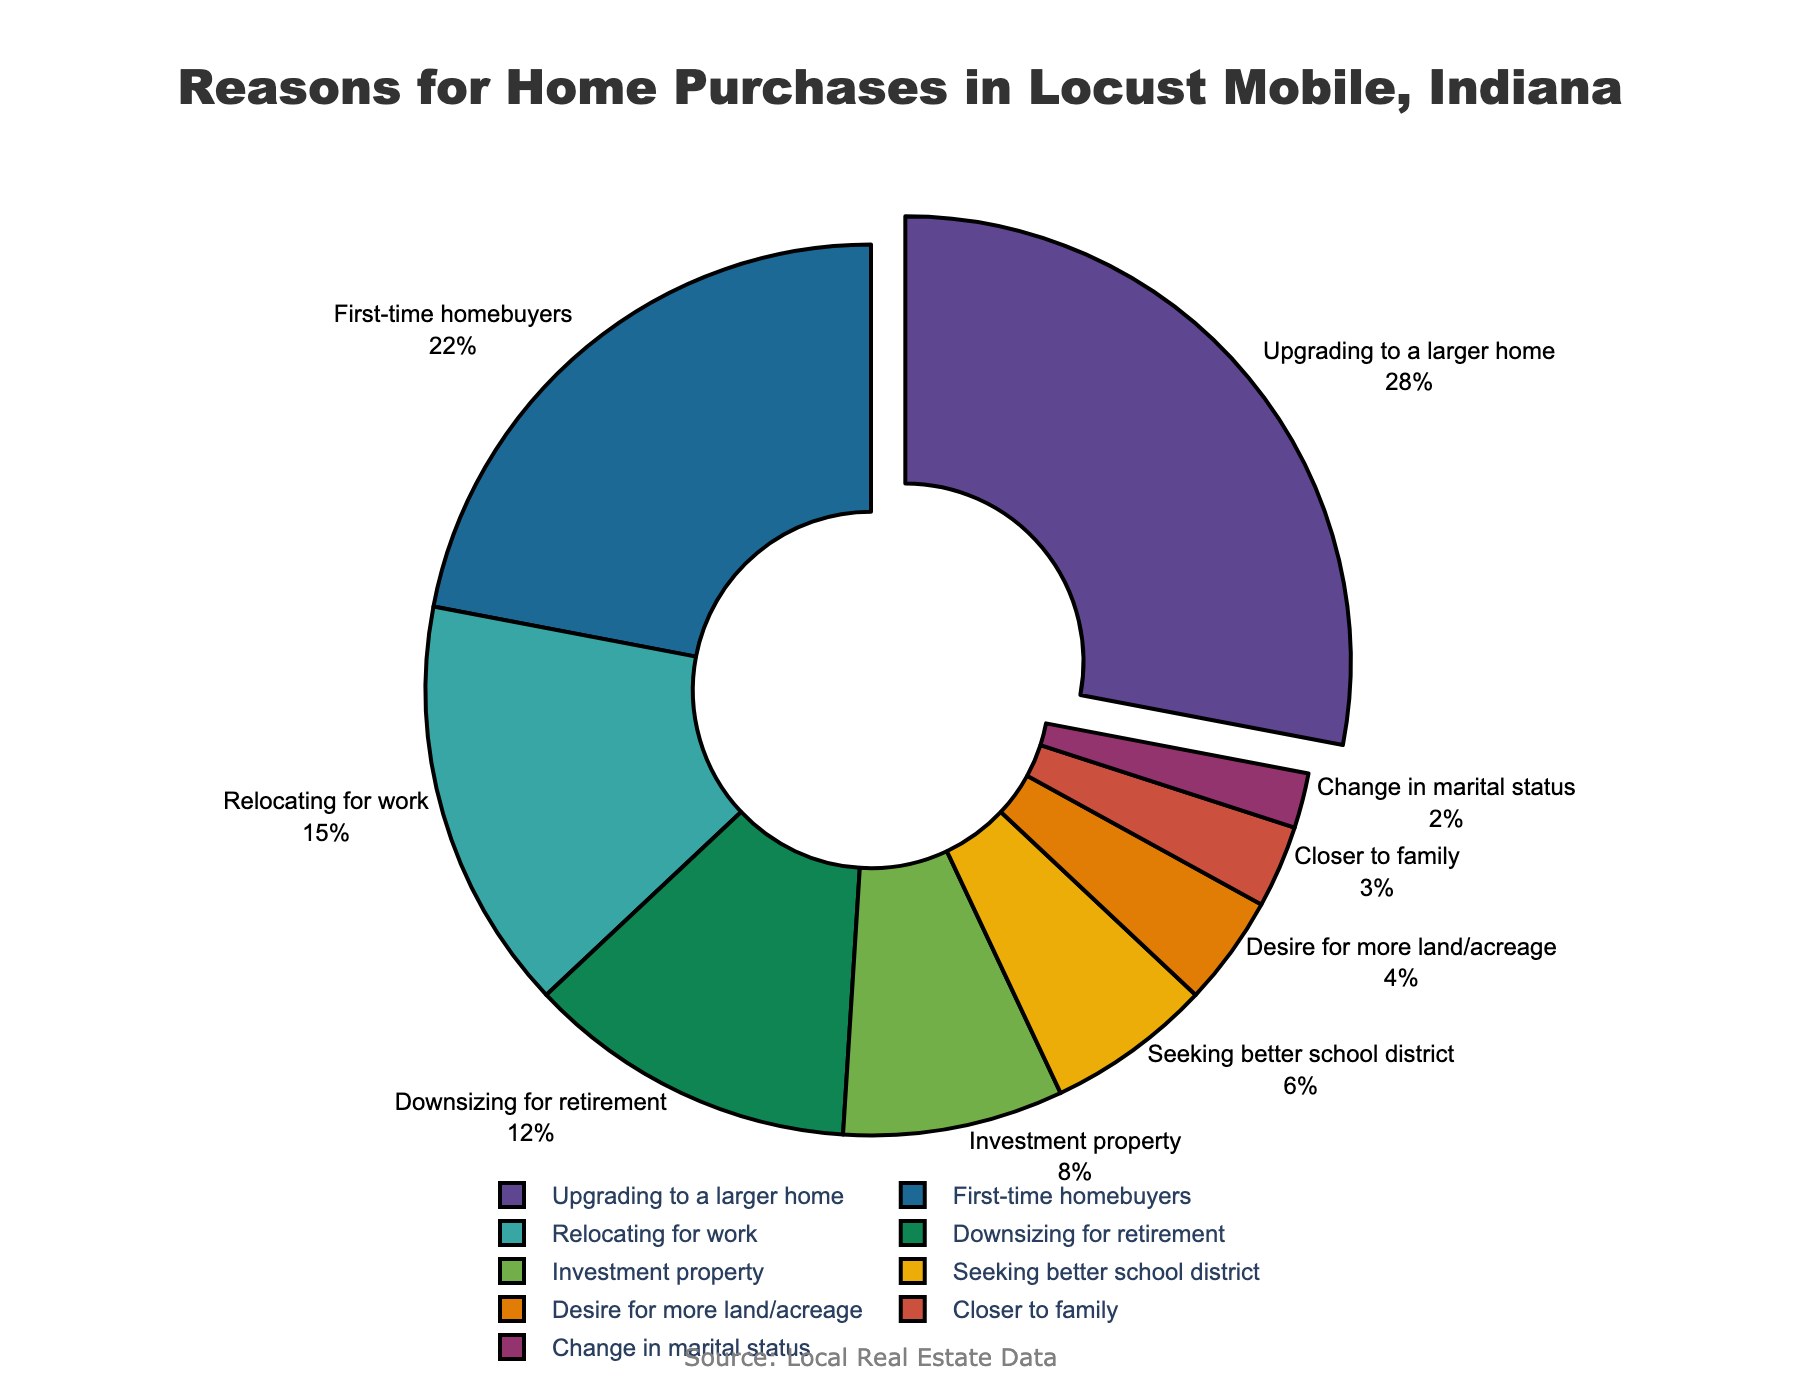What's the largest category among the reasons for home purchases? The largest category can be identified by the segment of the pie chart that is pulled out slightly and has the highest percentage labeled. This segment represents "Upgrading to a larger home" with 28%.
Answer: Upgrading to a larger home Which two categories together constitute exactly half of the reasons for home purchases? Adding the percentages of "Upgrading to a larger home" (28%) and "First-time homebuyers" (22%), we get 28% + 22% = 50%, which together amount to half of the reasons.
Answer: Upgrading to a larger home, First-time homebuyers How many percentage points more is "Relocating for work" compared to "Downsizing for retirement"? The percentage for "Relocating for work" is 15%, and for "Downsizing for retirement" is 12%. The difference is 15% - 12% = 3 percentage points more.
Answer: 3 percentage points What percentage of reasons for home purchases are related to "Seeking better school district" and "Desire for more land/acreage" combined? Adding the percentages for "Seeking better school district" (6%) and "Desire for more land/acreage" (4%), we get 6% + 4% = 10%.
Answer: 10% Which reason category for home purchases is visually represented with the smallest pie segment? By observing the smallest pie segment, it corresponds to "Change in marital status" with a percentage of 2%.
Answer: Change in marital status How does the percentage of "Investment property" compare with "Seeking better school district"? The percentage for "Investment property" is 8%, and for "Seeking better school district" is 6%. "Investment property" is 2% higher.
Answer: 2% higher If someone claims that "Closer to family" and "Change in marital status" together represent 6% of the pie, is this correct? Checking the values, "Closer to family" is 3% and "Change in marital status" is 2%. Together they add up to 3% + 2% = 5%, not 6%.
Answer: Incorrect, it's 5% Which reasons for home purchases combined do not exceed 20% of the total and are closely related to social factors? "Closer to family" (3%) and "Change in marital status" (2%) combined are 3% + 2% = 5%, which does not exceed 20%. They are closely related to social factors.
Answer: Closer to family, Change in marital status 